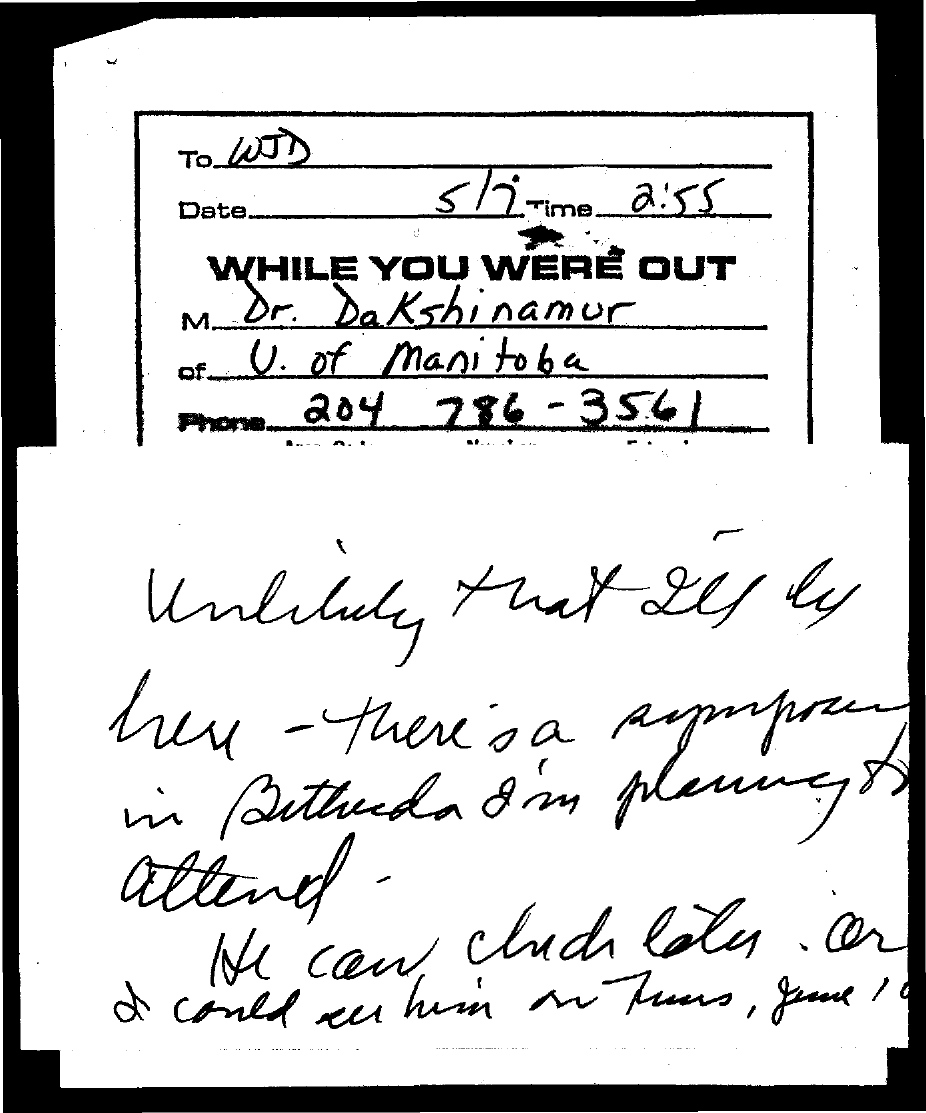Give some essential details in this illustration. The individual who is affiliated with the University of Manitoba is from there. The date on the document is 5/7. The time is currently 2:55. The phone number is 204 786 - 3561. The letter is from Dr. Dakshinamurthy. 